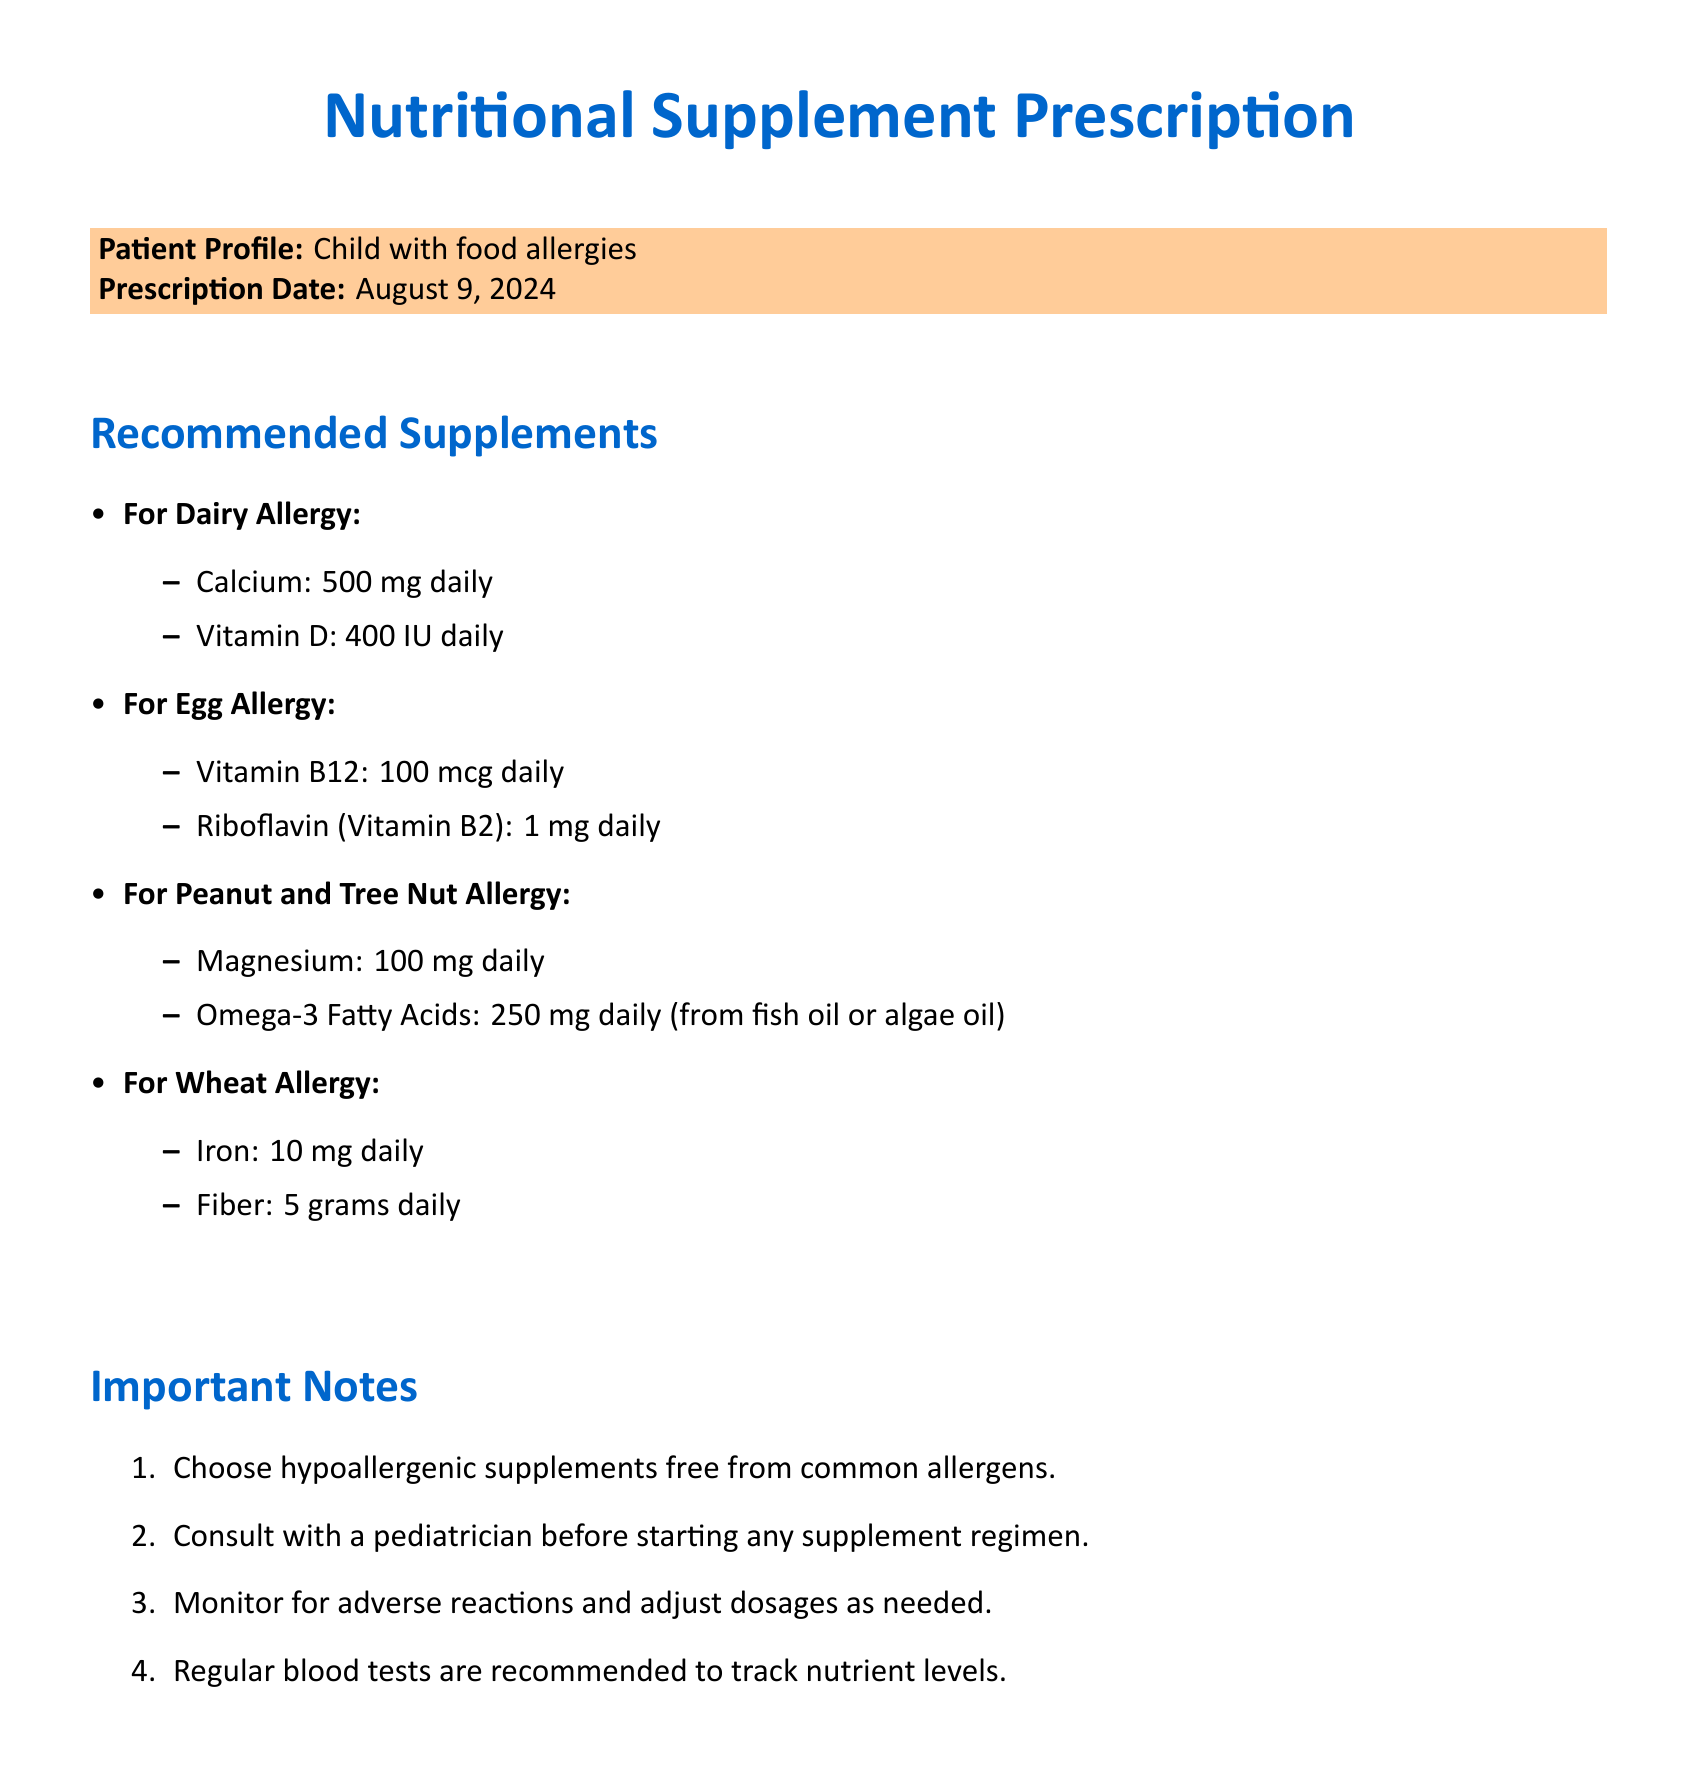what is the prescription date? The prescription date is mentioned in the document as "today," which indicates the current date of writing.
Answer: today what is the recommended daily intake of Vitamin D for a child with a dairy allergy? The document specifies the recommended daily intake of Vitamin D for a dairy allergy as 400 IU.
Answer: 400 IU which brand is recommended for hypoallergenic supplements? The document lists recommended brands for hypoallergenic supplements, including Kirkman Labs and Pure Encapsulations.
Answer: Kirkman Labs what supplement is recommended for a child with a peanut and tree nut allergy? The document indicates that Magnesium is recommended for a child with a peanut and tree nut allergy.
Answer: Magnesium how many milligrams of Calcium should be taken daily for a dairy allergy? The document states that the recommended daily intake of Calcium for a dairy allergy is 500 mg.
Answer: 500 mg what should be monitored when starting a supplement regimen? The document advises monitoring for adverse reactions when starting a supplement regimen.
Answer: Adverse reactions why is it important to consult a pediatrician before starting supplements? The document emphasizes the importance of consulting a pediatrician to ensure safety and appropriateness in supplement use.
Answer: Safety and appropriateness which vitamin is recommended for a child with an egg allergy? The document recommends Vitamin B12 for a child with an egg allergy.
Answer: Vitamin B12 what is the recommended daily intake of Fiber for a child with a wheat allergy? The document states that the recommended daily intake of Fiber for a wheat allergy is 5 grams.
Answer: 5 grams 